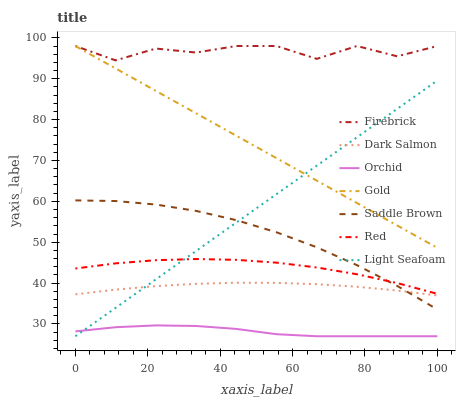Does Orchid have the minimum area under the curve?
Answer yes or no. Yes. Does Firebrick have the maximum area under the curve?
Answer yes or no. Yes. Does Dark Salmon have the minimum area under the curve?
Answer yes or no. No. Does Dark Salmon have the maximum area under the curve?
Answer yes or no. No. Is Gold the smoothest?
Answer yes or no. Yes. Is Firebrick the roughest?
Answer yes or no. Yes. Is Dark Salmon the smoothest?
Answer yes or no. No. Is Dark Salmon the roughest?
Answer yes or no. No. Does Light Seafoam have the lowest value?
Answer yes or no. Yes. Does Dark Salmon have the lowest value?
Answer yes or no. No. Does Firebrick have the highest value?
Answer yes or no. Yes. Does Dark Salmon have the highest value?
Answer yes or no. No. Is Orchid less than Red?
Answer yes or no. Yes. Is Firebrick greater than Light Seafoam?
Answer yes or no. Yes. Does Light Seafoam intersect Red?
Answer yes or no. Yes. Is Light Seafoam less than Red?
Answer yes or no. No. Is Light Seafoam greater than Red?
Answer yes or no. No. Does Orchid intersect Red?
Answer yes or no. No. 